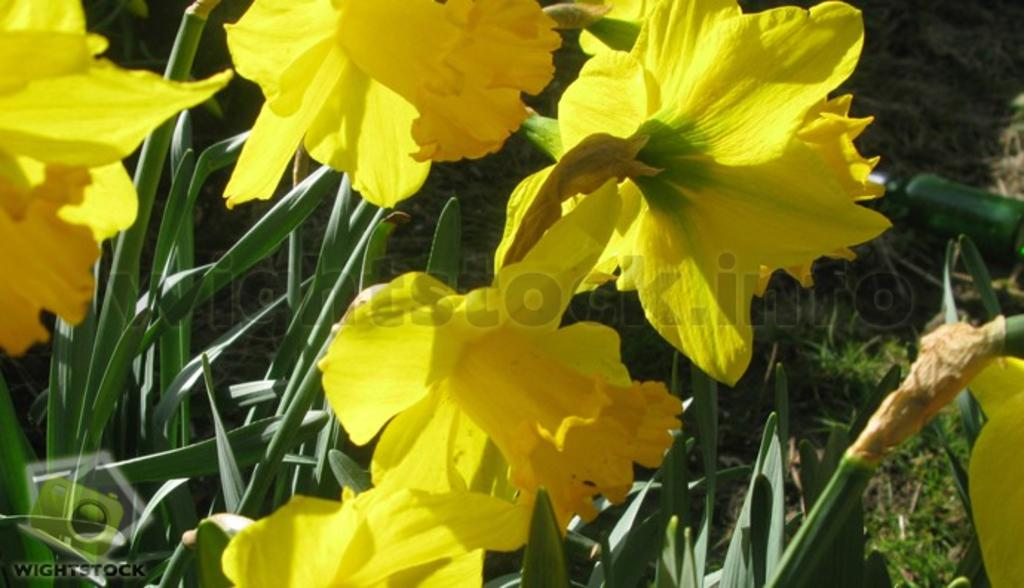What color are the flowers in the image? The flowers in the image are yellow. What are the flowers growing on? The flowers are on plants. What advice does the dad give in the image? There is no dad present in the image, and therefore no advice can be given. 